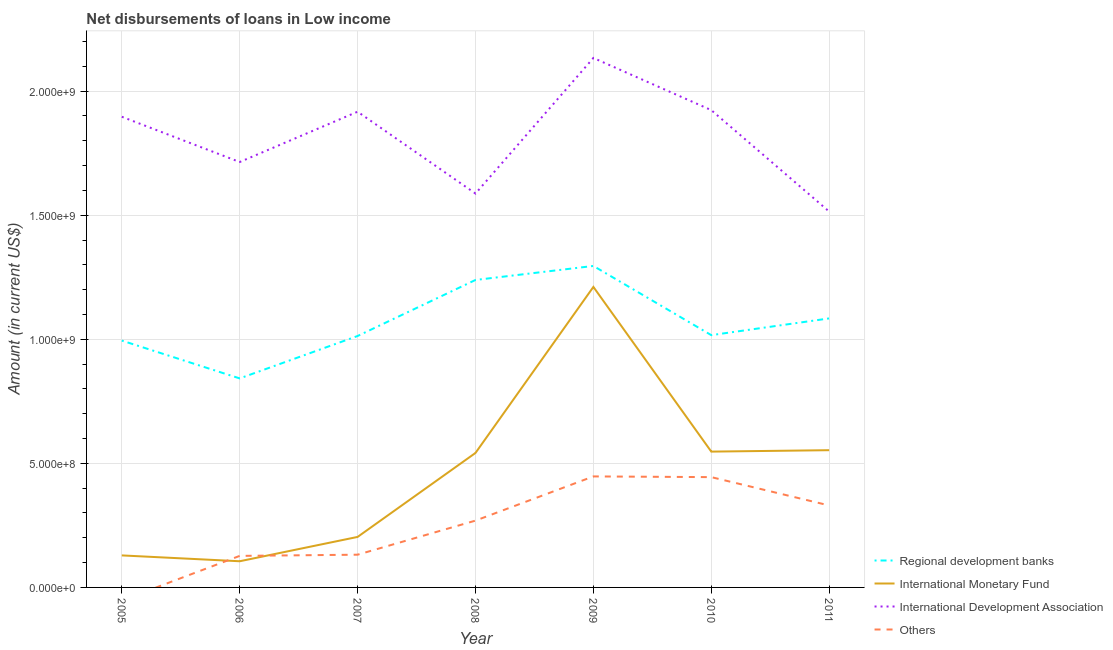How many different coloured lines are there?
Offer a terse response. 4. What is the amount of loan disimbursed by other organisations in 2011?
Offer a very short reply. 3.30e+08. Across all years, what is the maximum amount of loan disimbursed by international monetary fund?
Your answer should be compact. 1.21e+09. Across all years, what is the minimum amount of loan disimbursed by other organisations?
Provide a succinct answer. 0. In which year was the amount of loan disimbursed by regional development banks maximum?
Your answer should be compact. 2009. What is the total amount of loan disimbursed by regional development banks in the graph?
Provide a succinct answer. 7.49e+09. What is the difference between the amount of loan disimbursed by regional development banks in 2005 and that in 2006?
Your answer should be very brief. 1.52e+08. What is the difference between the amount of loan disimbursed by international monetary fund in 2009 and the amount of loan disimbursed by regional development banks in 2005?
Provide a succinct answer. 2.16e+08. What is the average amount of loan disimbursed by other organisations per year?
Offer a very short reply. 2.50e+08. In the year 2006, what is the difference between the amount of loan disimbursed by regional development banks and amount of loan disimbursed by international development association?
Ensure brevity in your answer.  -8.72e+08. What is the ratio of the amount of loan disimbursed by other organisations in 2007 to that in 2009?
Make the answer very short. 0.29. Is the amount of loan disimbursed by international development association in 2006 less than that in 2009?
Offer a very short reply. Yes. What is the difference between the highest and the second highest amount of loan disimbursed by international monetary fund?
Keep it short and to the point. 6.58e+08. What is the difference between the highest and the lowest amount of loan disimbursed by other organisations?
Keep it short and to the point. 4.47e+08. Is the sum of the amount of loan disimbursed by other organisations in 2008 and 2011 greater than the maximum amount of loan disimbursed by international development association across all years?
Give a very brief answer. No. Is it the case that in every year, the sum of the amount of loan disimbursed by international development association and amount of loan disimbursed by regional development banks is greater than the sum of amount of loan disimbursed by other organisations and amount of loan disimbursed by international monetary fund?
Offer a terse response. No. Is it the case that in every year, the sum of the amount of loan disimbursed by regional development banks and amount of loan disimbursed by international monetary fund is greater than the amount of loan disimbursed by international development association?
Offer a very short reply. No. Does the amount of loan disimbursed by international monetary fund monotonically increase over the years?
Your answer should be compact. No. Is the amount of loan disimbursed by international development association strictly greater than the amount of loan disimbursed by other organisations over the years?
Your response must be concise. Yes. Is the amount of loan disimbursed by international monetary fund strictly less than the amount of loan disimbursed by regional development banks over the years?
Provide a short and direct response. Yes. What is the difference between two consecutive major ticks on the Y-axis?
Give a very brief answer. 5.00e+08. Does the graph contain any zero values?
Make the answer very short. Yes. Does the graph contain grids?
Offer a terse response. Yes. What is the title of the graph?
Your answer should be compact. Net disbursements of loans in Low income. What is the label or title of the X-axis?
Your answer should be very brief. Year. What is the Amount (in current US$) of Regional development banks in 2005?
Your answer should be compact. 9.95e+08. What is the Amount (in current US$) of International Monetary Fund in 2005?
Provide a succinct answer. 1.29e+08. What is the Amount (in current US$) in International Development Association in 2005?
Keep it short and to the point. 1.90e+09. What is the Amount (in current US$) in Regional development banks in 2006?
Provide a succinct answer. 8.42e+08. What is the Amount (in current US$) in International Monetary Fund in 2006?
Provide a succinct answer. 1.05e+08. What is the Amount (in current US$) of International Development Association in 2006?
Offer a very short reply. 1.71e+09. What is the Amount (in current US$) in Others in 2006?
Your response must be concise. 1.27e+08. What is the Amount (in current US$) of Regional development banks in 2007?
Your answer should be compact. 1.01e+09. What is the Amount (in current US$) of International Monetary Fund in 2007?
Keep it short and to the point. 2.04e+08. What is the Amount (in current US$) of International Development Association in 2007?
Give a very brief answer. 1.92e+09. What is the Amount (in current US$) in Others in 2007?
Provide a short and direct response. 1.32e+08. What is the Amount (in current US$) in Regional development banks in 2008?
Offer a terse response. 1.24e+09. What is the Amount (in current US$) in International Monetary Fund in 2008?
Your answer should be compact. 5.42e+08. What is the Amount (in current US$) in International Development Association in 2008?
Your answer should be very brief. 1.59e+09. What is the Amount (in current US$) of Others in 2008?
Make the answer very short. 2.69e+08. What is the Amount (in current US$) in Regional development banks in 2009?
Offer a terse response. 1.30e+09. What is the Amount (in current US$) in International Monetary Fund in 2009?
Provide a short and direct response. 1.21e+09. What is the Amount (in current US$) in International Development Association in 2009?
Keep it short and to the point. 2.13e+09. What is the Amount (in current US$) in Others in 2009?
Ensure brevity in your answer.  4.47e+08. What is the Amount (in current US$) in Regional development banks in 2010?
Provide a succinct answer. 1.02e+09. What is the Amount (in current US$) in International Monetary Fund in 2010?
Offer a very short reply. 5.47e+08. What is the Amount (in current US$) in International Development Association in 2010?
Offer a very short reply. 1.92e+09. What is the Amount (in current US$) in Others in 2010?
Make the answer very short. 4.45e+08. What is the Amount (in current US$) in Regional development banks in 2011?
Your answer should be very brief. 1.08e+09. What is the Amount (in current US$) in International Monetary Fund in 2011?
Give a very brief answer. 5.53e+08. What is the Amount (in current US$) of International Development Association in 2011?
Your response must be concise. 1.51e+09. What is the Amount (in current US$) in Others in 2011?
Provide a short and direct response. 3.30e+08. Across all years, what is the maximum Amount (in current US$) in Regional development banks?
Provide a short and direct response. 1.30e+09. Across all years, what is the maximum Amount (in current US$) of International Monetary Fund?
Provide a succinct answer. 1.21e+09. Across all years, what is the maximum Amount (in current US$) of International Development Association?
Keep it short and to the point. 2.13e+09. Across all years, what is the maximum Amount (in current US$) in Others?
Offer a terse response. 4.47e+08. Across all years, what is the minimum Amount (in current US$) of Regional development banks?
Provide a succinct answer. 8.42e+08. Across all years, what is the minimum Amount (in current US$) of International Monetary Fund?
Keep it short and to the point. 1.05e+08. Across all years, what is the minimum Amount (in current US$) of International Development Association?
Your answer should be compact. 1.51e+09. What is the total Amount (in current US$) in Regional development banks in the graph?
Make the answer very short. 7.49e+09. What is the total Amount (in current US$) of International Monetary Fund in the graph?
Offer a terse response. 3.29e+09. What is the total Amount (in current US$) of International Development Association in the graph?
Your answer should be very brief. 1.27e+1. What is the total Amount (in current US$) in Others in the graph?
Offer a very short reply. 1.75e+09. What is the difference between the Amount (in current US$) in Regional development banks in 2005 and that in 2006?
Offer a terse response. 1.52e+08. What is the difference between the Amount (in current US$) of International Monetary Fund in 2005 and that in 2006?
Provide a short and direct response. 2.36e+07. What is the difference between the Amount (in current US$) in International Development Association in 2005 and that in 2006?
Offer a terse response. 1.82e+08. What is the difference between the Amount (in current US$) of Regional development banks in 2005 and that in 2007?
Provide a succinct answer. -1.85e+07. What is the difference between the Amount (in current US$) of International Monetary Fund in 2005 and that in 2007?
Keep it short and to the point. -7.45e+07. What is the difference between the Amount (in current US$) in International Development Association in 2005 and that in 2007?
Keep it short and to the point. -2.03e+07. What is the difference between the Amount (in current US$) in Regional development banks in 2005 and that in 2008?
Ensure brevity in your answer.  -2.44e+08. What is the difference between the Amount (in current US$) in International Monetary Fund in 2005 and that in 2008?
Offer a terse response. -4.13e+08. What is the difference between the Amount (in current US$) in International Development Association in 2005 and that in 2008?
Keep it short and to the point. 3.09e+08. What is the difference between the Amount (in current US$) of Regional development banks in 2005 and that in 2009?
Provide a short and direct response. -3.01e+08. What is the difference between the Amount (in current US$) in International Monetary Fund in 2005 and that in 2009?
Keep it short and to the point. -1.08e+09. What is the difference between the Amount (in current US$) of International Development Association in 2005 and that in 2009?
Provide a succinct answer. -2.37e+08. What is the difference between the Amount (in current US$) in Regional development banks in 2005 and that in 2010?
Give a very brief answer. -2.20e+07. What is the difference between the Amount (in current US$) in International Monetary Fund in 2005 and that in 2010?
Make the answer very short. -4.18e+08. What is the difference between the Amount (in current US$) in International Development Association in 2005 and that in 2010?
Provide a short and direct response. -2.67e+07. What is the difference between the Amount (in current US$) of Regional development banks in 2005 and that in 2011?
Provide a short and direct response. -8.94e+07. What is the difference between the Amount (in current US$) in International Monetary Fund in 2005 and that in 2011?
Your response must be concise. -4.24e+08. What is the difference between the Amount (in current US$) in International Development Association in 2005 and that in 2011?
Your answer should be very brief. 3.82e+08. What is the difference between the Amount (in current US$) of Regional development banks in 2006 and that in 2007?
Your response must be concise. -1.71e+08. What is the difference between the Amount (in current US$) of International Monetary Fund in 2006 and that in 2007?
Your response must be concise. -9.81e+07. What is the difference between the Amount (in current US$) in International Development Association in 2006 and that in 2007?
Your answer should be compact. -2.03e+08. What is the difference between the Amount (in current US$) in Others in 2006 and that in 2007?
Your answer should be very brief. -4.82e+06. What is the difference between the Amount (in current US$) of Regional development banks in 2006 and that in 2008?
Provide a succinct answer. -3.97e+08. What is the difference between the Amount (in current US$) of International Monetary Fund in 2006 and that in 2008?
Ensure brevity in your answer.  -4.37e+08. What is the difference between the Amount (in current US$) in International Development Association in 2006 and that in 2008?
Provide a short and direct response. 1.27e+08. What is the difference between the Amount (in current US$) of Others in 2006 and that in 2008?
Your answer should be compact. -1.42e+08. What is the difference between the Amount (in current US$) of Regional development banks in 2006 and that in 2009?
Keep it short and to the point. -4.53e+08. What is the difference between the Amount (in current US$) in International Monetary Fund in 2006 and that in 2009?
Provide a short and direct response. -1.11e+09. What is the difference between the Amount (in current US$) in International Development Association in 2006 and that in 2009?
Your answer should be compact. -4.19e+08. What is the difference between the Amount (in current US$) in Others in 2006 and that in 2009?
Your answer should be very brief. -3.20e+08. What is the difference between the Amount (in current US$) of Regional development banks in 2006 and that in 2010?
Provide a short and direct response. -1.74e+08. What is the difference between the Amount (in current US$) of International Monetary Fund in 2006 and that in 2010?
Keep it short and to the point. -4.42e+08. What is the difference between the Amount (in current US$) in International Development Association in 2006 and that in 2010?
Your response must be concise. -2.09e+08. What is the difference between the Amount (in current US$) in Others in 2006 and that in 2010?
Your response must be concise. -3.17e+08. What is the difference between the Amount (in current US$) of Regional development banks in 2006 and that in 2011?
Ensure brevity in your answer.  -2.42e+08. What is the difference between the Amount (in current US$) of International Monetary Fund in 2006 and that in 2011?
Offer a terse response. -4.48e+08. What is the difference between the Amount (in current US$) of International Development Association in 2006 and that in 2011?
Keep it short and to the point. 2.00e+08. What is the difference between the Amount (in current US$) in Others in 2006 and that in 2011?
Provide a succinct answer. -2.03e+08. What is the difference between the Amount (in current US$) in Regional development banks in 2007 and that in 2008?
Make the answer very short. -2.26e+08. What is the difference between the Amount (in current US$) of International Monetary Fund in 2007 and that in 2008?
Your answer should be very brief. -3.38e+08. What is the difference between the Amount (in current US$) of International Development Association in 2007 and that in 2008?
Your answer should be very brief. 3.30e+08. What is the difference between the Amount (in current US$) of Others in 2007 and that in 2008?
Offer a terse response. -1.37e+08. What is the difference between the Amount (in current US$) in Regional development banks in 2007 and that in 2009?
Provide a short and direct response. -2.82e+08. What is the difference between the Amount (in current US$) of International Monetary Fund in 2007 and that in 2009?
Ensure brevity in your answer.  -1.01e+09. What is the difference between the Amount (in current US$) of International Development Association in 2007 and that in 2009?
Your answer should be compact. -2.17e+08. What is the difference between the Amount (in current US$) in Others in 2007 and that in 2009?
Offer a very short reply. -3.15e+08. What is the difference between the Amount (in current US$) in Regional development banks in 2007 and that in 2010?
Offer a terse response. -3.46e+06. What is the difference between the Amount (in current US$) of International Monetary Fund in 2007 and that in 2010?
Provide a short and direct response. -3.44e+08. What is the difference between the Amount (in current US$) in International Development Association in 2007 and that in 2010?
Offer a very short reply. -6.39e+06. What is the difference between the Amount (in current US$) in Others in 2007 and that in 2010?
Ensure brevity in your answer.  -3.13e+08. What is the difference between the Amount (in current US$) of Regional development banks in 2007 and that in 2011?
Your response must be concise. -7.09e+07. What is the difference between the Amount (in current US$) of International Monetary Fund in 2007 and that in 2011?
Give a very brief answer. -3.50e+08. What is the difference between the Amount (in current US$) in International Development Association in 2007 and that in 2011?
Make the answer very short. 4.02e+08. What is the difference between the Amount (in current US$) of Others in 2007 and that in 2011?
Ensure brevity in your answer.  -1.98e+08. What is the difference between the Amount (in current US$) of Regional development banks in 2008 and that in 2009?
Make the answer very short. -5.64e+07. What is the difference between the Amount (in current US$) in International Monetary Fund in 2008 and that in 2009?
Provide a short and direct response. -6.69e+08. What is the difference between the Amount (in current US$) in International Development Association in 2008 and that in 2009?
Offer a terse response. -5.46e+08. What is the difference between the Amount (in current US$) in Others in 2008 and that in 2009?
Offer a terse response. -1.78e+08. What is the difference between the Amount (in current US$) of Regional development banks in 2008 and that in 2010?
Provide a succinct answer. 2.22e+08. What is the difference between the Amount (in current US$) of International Monetary Fund in 2008 and that in 2010?
Keep it short and to the point. -5.36e+06. What is the difference between the Amount (in current US$) of International Development Association in 2008 and that in 2010?
Give a very brief answer. -3.36e+08. What is the difference between the Amount (in current US$) of Others in 2008 and that in 2010?
Your response must be concise. -1.75e+08. What is the difference between the Amount (in current US$) of Regional development banks in 2008 and that in 2011?
Make the answer very short. 1.55e+08. What is the difference between the Amount (in current US$) in International Monetary Fund in 2008 and that in 2011?
Offer a very short reply. -1.11e+07. What is the difference between the Amount (in current US$) of International Development Association in 2008 and that in 2011?
Make the answer very short. 7.26e+07. What is the difference between the Amount (in current US$) in Others in 2008 and that in 2011?
Your answer should be compact. -6.11e+07. What is the difference between the Amount (in current US$) of Regional development banks in 2009 and that in 2010?
Ensure brevity in your answer.  2.79e+08. What is the difference between the Amount (in current US$) of International Monetary Fund in 2009 and that in 2010?
Provide a succinct answer. 6.64e+08. What is the difference between the Amount (in current US$) in International Development Association in 2009 and that in 2010?
Your answer should be compact. 2.10e+08. What is the difference between the Amount (in current US$) in Others in 2009 and that in 2010?
Your answer should be very brief. 2.87e+06. What is the difference between the Amount (in current US$) of Regional development banks in 2009 and that in 2011?
Ensure brevity in your answer.  2.11e+08. What is the difference between the Amount (in current US$) in International Monetary Fund in 2009 and that in 2011?
Your answer should be very brief. 6.58e+08. What is the difference between the Amount (in current US$) of International Development Association in 2009 and that in 2011?
Your response must be concise. 6.19e+08. What is the difference between the Amount (in current US$) in Others in 2009 and that in 2011?
Your response must be concise. 1.17e+08. What is the difference between the Amount (in current US$) in Regional development banks in 2010 and that in 2011?
Make the answer very short. -6.74e+07. What is the difference between the Amount (in current US$) of International Monetary Fund in 2010 and that in 2011?
Make the answer very short. -5.76e+06. What is the difference between the Amount (in current US$) in International Development Association in 2010 and that in 2011?
Your response must be concise. 4.09e+08. What is the difference between the Amount (in current US$) in Others in 2010 and that in 2011?
Make the answer very short. 1.14e+08. What is the difference between the Amount (in current US$) in Regional development banks in 2005 and the Amount (in current US$) in International Monetary Fund in 2006?
Your answer should be very brief. 8.89e+08. What is the difference between the Amount (in current US$) in Regional development banks in 2005 and the Amount (in current US$) in International Development Association in 2006?
Give a very brief answer. -7.20e+08. What is the difference between the Amount (in current US$) of Regional development banks in 2005 and the Amount (in current US$) of Others in 2006?
Offer a very short reply. 8.68e+08. What is the difference between the Amount (in current US$) in International Monetary Fund in 2005 and the Amount (in current US$) in International Development Association in 2006?
Your answer should be very brief. -1.59e+09. What is the difference between the Amount (in current US$) of International Monetary Fund in 2005 and the Amount (in current US$) of Others in 2006?
Your answer should be compact. 1.95e+06. What is the difference between the Amount (in current US$) in International Development Association in 2005 and the Amount (in current US$) in Others in 2006?
Your answer should be very brief. 1.77e+09. What is the difference between the Amount (in current US$) of Regional development banks in 2005 and the Amount (in current US$) of International Monetary Fund in 2007?
Your answer should be compact. 7.91e+08. What is the difference between the Amount (in current US$) of Regional development banks in 2005 and the Amount (in current US$) of International Development Association in 2007?
Keep it short and to the point. -9.22e+08. What is the difference between the Amount (in current US$) of Regional development banks in 2005 and the Amount (in current US$) of Others in 2007?
Your answer should be compact. 8.63e+08. What is the difference between the Amount (in current US$) in International Monetary Fund in 2005 and the Amount (in current US$) in International Development Association in 2007?
Offer a terse response. -1.79e+09. What is the difference between the Amount (in current US$) in International Monetary Fund in 2005 and the Amount (in current US$) in Others in 2007?
Your response must be concise. -2.87e+06. What is the difference between the Amount (in current US$) of International Development Association in 2005 and the Amount (in current US$) of Others in 2007?
Your answer should be very brief. 1.76e+09. What is the difference between the Amount (in current US$) in Regional development banks in 2005 and the Amount (in current US$) in International Monetary Fund in 2008?
Ensure brevity in your answer.  4.53e+08. What is the difference between the Amount (in current US$) in Regional development banks in 2005 and the Amount (in current US$) in International Development Association in 2008?
Ensure brevity in your answer.  -5.93e+08. What is the difference between the Amount (in current US$) of Regional development banks in 2005 and the Amount (in current US$) of Others in 2008?
Give a very brief answer. 7.26e+08. What is the difference between the Amount (in current US$) in International Monetary Fund in 2005 and the Amount (in current US$) in International Development Association in 2008?
Make the answer very short. -1.46e+09. What is the difference between the Amount (in current US$) of International Monetary Fund in 2005 and the Amount (in current US$) of Others in 2008?
Your response must be concise. -1.40e+08. What is the difference between the Amount (in current US$) of International Development Association in 2005 and the Amount (in current US$) of Others in 2008?
Provide a short and direct response. 1.63e+09. What is the difference between the Amount (in current US$) of Regional development banks in 2005 and the Amount (in current US$) of International Monetary Fund in 2009?
Your answer should be compact. -2.16e+08. What is the difference between the Amount (in current US$) in Regional development banks in 2005 and the Amount (in current US$) in International Development Association in 2009?
Your answer should be very brief. -1.14e+09. What is the difference between the Amount (in current US$) in Regional development banks in 2005 and the Amount (in current US$) in Others in 2009?
Keep it short and to the point. 5.47e+08. What is the difference between the Amount (in current US$) of International Monetary Fund in 2005 and the Amount (in current US$) of International Development Association in 2009?
Ensure brevity in your answer.  -2.00e+09. What is the difference between the Amount (in current US$) of International Monetary Fund in 2005 and the Amount (in current US$) of Others in 2009?
Keep it short and to the point. -3.18e+08. What is the difference between the Amount (in current US$) of International Development Association in 2005 and the Amount (in current US$) of Others in 2009?
Your answer should be compact. 1.45e+09. What is the difference between the Amount (in current US$) in Regional development banks in 2005 and the Amount (in current US$) in International Monetary Fund in 2010?
Your response must be concise. 4.47e+08. What is the difference between the Amount (in current US$) of Regional development banks in 2005 and the Amount (in current US$) of International Development Association in 2010?
Your answer should be compact. -9.29e+08. What is the difference between the Amount (in current US$) in Regional development banks in 2005 and the Amount (in current US$) in Others in 2010?
Keep it short and to the point. 5.50e+08. What is the difference between the Amount (in current US$) of International Monetary Fund in 2005 and the Amount (in current US$) of International Development Association in 2010?
Keep it short and to the point. -1.79e+09. What is the difference between the Amount (in current US$) in International Monetary Fund in 2005 and the Amount (in current US$) in Others in 2010?
Ensure brevity in your answer.  -3.15e+08. What is the difference between the Amount (in current US$) in International Development Association in 2005 and the Amount (in current US$) in Others in 2010?
Your answer should be very brief. 1.45e+09. What is the difference between the Amount (in current US$) in Regional development banks in 2005 and the Amount (in current US$) in International Monetary Fund in 2011?
Your answer should be compact. 4.42e+08. What is the difference between the Amount (in current US$) in Regional development banks in 2005 and the Amount (in current US$) in International Development Association in 2011?
Your answer should be compact. -5.20e+08. What is the difference between the Amount (in current US$) of Regional development banks in 2005 and the Amount (in current US$) of Others in 2011?
Offer a terse response. 6.64e+08. What is the difference between the Amount (in current US$) of International Monetary Fund in 2005 and the Amount (in current US$) of International Development Association in 2011?
Offer a very short reply. -1.39e+09. What is the difference between the Amount (in current US$) in International Monetary Fund in 2005 and the Amount (in current US$) in Others in 2011?
Offer a very short reply. -2.01e+08. What is the difference between the Amount (in current US$) in International Development Association in 2005 and the Amount (in current US$) in Others in 2011?
Give a very brief answer. 1.57e+09. What is the difference between the Amount (in current US$) in Regional development banks in 2006 and the Amount (in current US$) in International Monetary Fund in 2007?
Your answer should be very brief. 6.39e+08. What is the difference between the Amount (in current US$) in Regional development banks in 2006 and the Amount (in current US$) in International Development Association in 2007?
Provide a succinct answer. -1.07e+09. What is the difference between the Amount (in current US$) in Regional development banks in 2006 and the Amount (in current US$) in Others in 2007?
Your answer should be compact. 7.10e+08. What is the difference between the Amount (in current US$) of International Monetary Fund in 2006 and the Amount (in current US$) of International Development Association in 2007?
Offer a terse response. -1.81e+09. What is the difference between the Amount (in current US$) in International Monetary Fund in 2006 and the Amount (in current US$) in Others in 2007?
Make the answer very short. -2.64e+07. What is the difference between the Amount (in current US$) of International Development Association in 2006 and the Amount (in current US$) of Others in 2007?
Offer a terse response. 1.58e+09. What is the difference between the Amount (in current US$) in Regional development banks in 2006 and the Amount (in current US$) in International Monetary Fund in 2008?
Your answer should be compact. 3.00e+08. What is the difference between the Amount (in current US$) of Regional development banks in 2006 and the Amount (in current US$) of International Development Association in 2008?
Your answer should be compact. -7.45e+08. What is the difference between the Amount (in current US$) of Regional development banks in 2006 and the Amount (in current US$) of Others in 2008?
Your answer should be compact. 5.73e+08. What is the difference between the Amount (in current US$) in International Monetary Fund in 2006 and the Amount (in current US$) in International Development Association in 2008?
Keep it short and to the point. -1.48e+09. What is the difference between the Amount (in current US$) of International Monetary Fund in 2006 and the Amount (in current US$) of Others in 2008?
Offer a terse response. -1.64e+08. What is the difference between the Amount (in current US$) in International Development Association in 2006 and the Amount (in current US$) in Others in 2008?
Offer a very short reply. 1.45e+09. What is the difference between the Amount (in current US$) of Regional development banks in 2006 and the Amount (in current US$) of International Monetary Fund in 2009?
Provide a succinct answer. -3.69e+08. What is the difference between the Amount (in current US$) of Regional development banks in 2006 and the Amount (in current US$) of International Development Association in 2009?
Your answer should be compact. -1.29e+09. What is the difference between the Amount (in current US$) of Regional development banks in 2006 and the Amount (in current US$) of Others in 2009?
Your answer should be very brief. 3.95e+08. What is the difference between the Amount (in current US$) in International Monetary Fund in 2006 and the Amount (in current US$) in International Development Association in 2009?
Your answer should be compact. -2.03e+09. What is the difference between the Amount (in current US$) in International Monetary Fund in 2006 and the Amount (in current US$) in Others in 2009?
Your answer should be very brief. -3.42e+08. What is the difference between the Amount (in current US$) of International Development Association in 2006 and the Amount (in current US$) of Others in 2009?
Offer a terse response. 1.27e+09. What is the difference between the Amount (in current US$) in Regional development banks in 2006 and the Amount (in current US$) in International Monetary Fund in 2010?
Make the answer very short. 2.95e+08. What is the difference between the Amount (in current US$) in Regional development banks in 2006 and the Amount (in current US$) in International Development Association in 2010?
Your response must be concise. -1.08e+09. What is the difference between the Amount (in current US$) of Regional development banks in 2006 and the Amount (in current US$) of Others in 2010?
Your answer should be compact. 3.98e+08. What is the difference between the Amount (in current US$) of International Monetary Fund in 2006 and the Amount (in current US$) of International Development Association in 2010?
Give a very brief answer. -1.82e+09. What is the difference between the Amount (in current US$) in International Monetary Fund in 2006 and the Amount (in current US$) in Others in 2010?
Provide a succinct answer. -3.39e+08. What is the difference between the Amount (in current US$) of International Development Association in 2006 and the Amount (in current US$) of Others in 2010?
Your answer should be compact. 1.27e+09. What is the difference between the Amount (in current US$) of Regional development banks in 2006 and the Amount (in current US$) of International Monetary Fund in 2011?
Your answer should be compact. 2.89e+08. What is the difference between the Amount (in current US$) in Regional development banks in 2006 and the Amount (in current US$) in International Development Association in 2011?
Your answer should be very brief. -6.72e+08. What is the difference between the Amount (in current US$) of Regional development banks in 2006 and the Amount (in current US$) of Others in 2011?
Your answer should be very brief. 5.12e+08. What is the difference between the Amount (in current US$) in International Monetary Fund in 2006 and the Amount (in current US$) in International Development Association in 2011?
Your response must be concise. -1.41e+09. What is the difference between the Amount (in current US$) of International Monetary Fund in 2006 and the Amount (in current US$) of Others in 2011?
Make the answer very short. -2.25e+08. What is the difference between the Amount (in current US$) of International Development Association in 2006 and the Amount (in current US$) of Others in 2011?
Your answer should be very brief. 1.38e+09. What is the difference between the Amount (in current US$) of Regional development banks in 2007 and the Amount (in current US$) of International Monetary Fund in 2008?
Give a very brief answer. 4.71e+08. What is the difference between the Amount (in current US$) in Regional development banks in 2007 and the Amount (in current US$) in International Development Association in 2008?
Your answer should be very brief. -5.74e+08. What is the difference between the Amount (in current US$) of Regional development banks in 2007 and the Amount (in current US$) of Others in 2008?
Provide a succinct answer. 7.44e+08. What is the difference between the Amount (in current US$) in International Monetary Fund in 2007 and the Amount (in current US$) in International Development Association in 2008?
Keep it short and to the point. -1.38e+09. What is the difference between the Amount (in current US$) of International Monetary Fund in 2007 and the Amount (in current US$) of Others in 2008?
Ensure brevity in your answer.  -6.57e+07. What is the difference between the Amount (in current US$) of International Development Association in 2007 and the Amount (in current US$) of Others in 2008?
Offer a very short reply. 1.65e+09. What is the difference between the Amount (in current US$) of Regional development banks in 2007 and the Amount (in current US$) of International Monetary Fund in 2009?
Keep it short and to the point. -1.98e+08. What is the difference between the Amount (in current US$) in Regional development banks in 2007 and the Amount (in current US$) in International Development Association in 2009?
Provide a succinct answer. -1.12e+09. What is the difference between the Amount (in current US$) in Regional development banks in 2007 and the Amount (in current US$) in Others in 2009?
Offer a very short reply. 5.66e+08. What is the difference between the Amount (in current US$) in International Monetary Fund in 2007 and the Amount (in current US$) in International Development Association in 2009?
Your answer should be compact. -1.93e+09. What is the difference between the Amount (in current US$) of International Monetary Fund in 2007 and the Amount (in current US$) of Others in 2009?
Give a very brief answer. -2.44e+08. What is the difference between the Amount (in current US$) of International Development Association in 2007 and the Amount (in current US$) of Others in 2009?
Offer a very short reply. 1.47e+09. What is the difference between the Amount (in current US$) of Regional development banks in 2007 and the Amount (in current US$) of International Monetary Fund in 2010?
Provide a succinct answer. 4.66e+08. What is the difference between the Amount (in current US$) of Regional development banks in 2007 and the Amount (in current US$) of International Development Association in 2010?
Offer a very short reply. -9.10e+08. What is the difference between the Amount (in current US$) of Regional development banks in 2007 and the Amount (in current US$) of Others in 2010?
Your answer should be compact. 5.69e+08. What is the difference between the Amount (in current US$) in International Monetary Fund in 2007 and the Amount (in current US$) in International Development Association in 2010?
Your response must be concise. -1.72e+09. What is the difference between the Amount (in current US$) of International Monetary Fund in 2007 and the Amount (in current US$) of Others in 2010?
Make the answer very short. -2.41e+08. What is the difference between the Amount (in current US$) of International Development Association in 2007 and the Amount (in current US$) of Others in 2010?
Your response must be concise. 1.47e+09. What is the difference between the Amount (in current US$) in Regional development banks in 2007 and the Amount (in current US$) in International Monetary Fund in 2011?
Your answer should be very brief. 4.60e+08. What is the difference between the Amount (in current US$) in Regional development banks in 2007 and the Amount (in current US$) in International Development Association in 2011?
Make the answer very short. -5.02e+08. What is the difference between the Amount (in current US$) of Regional development banks in 2007 and the Amount (in current US$) of Others in 2011?
Make the answer very short. 6.83e+08. What is the difference between the Amount (in current US$) of International Monetary Fund in 2007 and the Amount (in current US$) of International Development Association in 2011?
Give a very brief answer. -1.31e+09. What is the difference between the Amount (in current US$) in International Monetary Fund in 2007 and the Amount (in current US$) in Others in 2011?
Your answer should be very brief. -1.27e+08. What is the difference between the Amount (in current US$) of International Development Association in 2007 and the Amount (in current US$) of Others in 2011?
Ensure brevity in your answer.  1.59e+09. What is the difference between the Amount (in current US$) of Regional development banks in 2008 and the Amount (in current US$) of International Monetary Fund in 2009?
Ensure brevity in your answer.  2.81e+07. What is the difference between the Amount (in current US$) in Regional development banks in 2008 and the Amount (in current US$) in International Development Association in 2009?
Keep it short and to the point. -8.95e+08. What is the difference between the Amount (in current US$) in Regional development banks in 2008 and the Amount (in current US$) in Others in 2009?
Keep it short and to the point. 7.92e+08. What is the difference between the Amount (in current US$) in International Monetary Fund in 2008 and the Amount (in current US$) in International Development Association in 2009?
Your answer should be very brief. -1.59e+09. What is the difference between the Amount (in current US$) in International Monetary Fund in 2008 and the Amount (in current US$) in Others in 2009?
Offer a very short reply. 9.46e+07. What is the difference between the Amount (in current US$) in International Development Association in 2008 and the Amount (in current US$) in Others in 2009?
Your answer should be compact. 1.14e+09. What is the difference between the Amount (in current US$) of Regional development banks in 2008 and the Amount (in current US$) of International Monetary Fund in 2010?
Make the answer very short. 6.92e+08. What is the difference between the Amount (in current US$) of Regional development banks in 2008 and the Amount (in current US$) of International Development Association in 2010?
Offer a terse response. -6.84e+08. What is the difference between the Amount (in current US$) in Regional development banks in 2008 and the Amount (in current US$) in Others in 2010?
Provide a succinct answer. 7.95e+08. What is the difference between the Amount (in current US$) of International Monetary Fund in 2008 and the Amount (in current US$) of International Development Association in 2010?
Your answer should be very brief. -1.38e+09. What is the difference between the Amount (in current US$) in International Monetary Fund in 2008 and the Amount (in current US$) in Others in 2010?
Your answer should be compact. 9.75e+07. What is the difference between the Amount (in current US$) of International Development Association in 2008 and the Amount (in current US$) of Others in 2010?
Keep it short and to the point. 1.14e+09. What is the difference between the Amount (in current US$) of Regional development banks in 2008 and the Amount (in current US$) of International Monetary Fund in 2011?
Offer a very short reply. 6.86e+08. What is the difference between the Amount (in current US$) of Regional development banks in 2008 and the Amount (in current US$) of International Development Association in 2011?
Your response must be concise. -2.76e+08. What is the difference between the Amount (in current US$) of Regional development banks in 2008 and the Amount (in current US$) of Others in 2011?
Ensure brevity in your answer.  9.09e+08. What is the difference between the Amount (in current US$) of International Monetary Fund in 2008 and the Amount (in current US$) of International Development Association in 2011?
Provide a succinct answer. -9.73e+08. What is the difference between the Amount (in current US$) of International Monetary Fund in 2008 and the Amount (in current US$) of Others in 2011?
Your answer should be compact. 2.12e+08. What is the difference between the Amount (in current US$) of International Development Association in 2008 and the Amount (in current US$) of Others in 2011?
Provide a succinct answer. 1.26e+09. What is the difference between the Amount (in current US$) in Regional development banks in 2009 and the Amount (in current US$) in International Monetary Fund in 2010?
Ensure brevity in your answer.  7.48e+08. What is the difference between the Amount (in current US$) in Regional development banks in 2009 and the Amount (in current US$) in International Development Association in 2010?
Make the answer very short. -6.28e+08. What is the difference between the Amount (in current US$) in Regional development banks in 2009 and the Amount (in current US$) in Others in 2010?
Your answer should be very brief. 8.51e+08. What is the difference between the Amount (in current US$) in International Monetary Fund in 2009 and the Amount (in current US$) in International Development Association in 2010?
Keep it short and to the point. -7.12e+08. What is the difference between the Amount (in current US$) of International Monetary Fund in 2009 and the Amount (in current US$) of Others in 2010?
Your response must be concise. 7.67e+08. What is the difference between the Amount (in current US$) in International Development Association in 2009 and the Amount (in current US$) in Others in 2010?
Offer a terse response. 1.69e+09. What is the difference between the Amount (in current US$) in Regional development banks in 2009 and the Amount (in current US$) in International Monetary Fund in 2011?
Make the answer very short. 7.42e+08. What is the difference between the Amount (in current US$) of Regional development banks in 2009 and the Amount (in current US$) of International Development Association in 2011?
Offer a terse response. -2.19e+08. What is the difference between the Amount (in current US$) in Regional development banks in 2009 and the Amount (in current US$) in Others in 2011?
Ensure brevity in your answer.  9.65e+08. What is the difference between the Amount (in current US$) in International Monetary Fund in 2009 and the Amount (in current US$) in International Development Association in 2011?
Keep it short and to the point. -3.04e+08. What is the difference between the Amount (in current US$) of International Monetary Fund in 2009 and the Amount (in current US$) of Others in 2011?
Keep it short and to the point. 8.81e+08. What is the difference between the Amount (in current US$) in International Development Association in 2009 and the Amount (in current US$) in Others in 2011?
Give a very brief answer. 1.80e+09. What is the difference between the Amount (in current US$) in Regional development banks in 2010 and the Amount (in current US$) in International Monetary Fund in 2011?
Your answer should be very brief. 4.64e+08. What is the difference between the Amount (in current US$) in Regional development banks in 2010 and the Amount (in current US$) in International Development Association in 2011?
Keep it short and to the point. -4.98e+08. What is the difference between the Amount (in current US$) of Regional development banks in 2010 and the Amount (in current US$) of Others in 2011?
Ensure brevity in your answer.  6.86e+08. What is the difference between the Amount (in current US$) in International Monetary Fund in 2010 and the Amount (in current US$) in International Development Association in 2011?
Provide a short and direct response. -9.68e+08. What is the difference between the Amount (in current US$) of International Monetary Fund in 2010 and the Amount (in current US$) of Others in 2011?
Make the answer very short. 2.17e+08. What is the difference between the Amount (in current US$) of International Development Association in 2010 and the Amount (in current US$) of Others in 2011?
Your answer should be compact. 1.59e+09. What is the average Amount (in current US$) of Regional development banks per year?
Your answer should be very brief. 1.07e+09. What is the average Amount (in current US$) in International Monetary Fund per year?
Provide a succinct answer. 4.70e+08. What is the average Amount (in current US$) in International Development Association per year?
Your answer should be compact. 1.81e+09. What is the average Amount (in current US$) of Others per year?
Keep it short and to the point. 2.50e+08. In the year 2005, what is the difference between the Amount (in current US$) of Regional development banks and Amount (in current US$) of International Monetary Fund?
Provide a succinct answer. 8.66e+08. In the year 2005, what is the difference between the Amount (in current US$) of Regional development banks and Amount (in current US$) of International Development Association?
Provide a short and direct response. -9.02e+08. In the year 2005, what is the difference between the Amount (in current US$) in International Monetary Fund and Amount (in current US$) in International Development Association?
Make the answer very short. -1.77e+09. In the year 2006, what is the difference between the Amount (in current US$) in Regional development banks and Amount (in current US$) in International Monetary Fund?
Offer a very short reply. 7.37e+08. In the year 2006, what is the difference between the Amount (in current US$) of Regional development banks and Amount (in current US$) of International Development Association?
Provide a short and direct response. -8.72e+08. In the year 2006, what is the difference between the Amount (in current US$) in Regional development banks and Amount (in current US$) in Others?
Provide a short and direct response. 7.15e+08. In the year 2006, what is the difference between the Amount (in current US$) in International Monetary Fund and Amount (in current US$) in International Development Association?
Provide a succinct answer. -1.61e+09. In the year 2006, what is the difference between the Amount (in current US$) of International Monetary Fund and Amount (in current US$) of Others?
Ensure brevity in your answer.  -2.16e+07. In the year 2006, what is the difference between the Amount (in current US$) in International Development Association and Amount (in current US$) in Others?
Offer a very short reply. 1.59e+09. In the year 2007, what is the difference between the Amount (in current US$) in Regional development banks and Amount (in current US$) in International Monetary Fund?
Give a very brief answer. 8.10e+08. In the year 2007, what is the difference between the Amount (in current US$) in Regional development banks and Amount (in current US$) in International Development Association?
Make the answer very short. -9.04e+08. In the year 2007, what is the difference between the Amount (in current US$) of Regional development banks and Amount (in current US$) of Others?
Keep it short and to the point. 8.81e+08. In the year 2007, what is the difference between the Amount (in current US$) in International Monetary Fund and Amount (in current US$) in International Development Association?
Your answer should be compact. -1.71e+09. In the year 2007, what is the difference between the Amount (in current US$) in International Monetary Fund and Amount (in current US$) in Others?
Offer a terse response. 7.16e+07. In the year 2007, what is the difference between the Amount (in current US$) in International Development Association and Amount (in current US$) in Others?
Ensure brevity in your answer.  1.79e+09. In the year 2008, what is the difference between the Amount (in current US$) of Regional development banks and Amount (in current US$) of International Monetary Fund?
Give a very brief answer. 6.97e+08. In the year 2008, what is the difference between the Amount (in current US$) in Regional development banks and Amount (in current US$) in International Development Association?
Keep it short and to the point. -3.48e+08. In the year 2008, what is the difference between the Amount (in current US$) in Regional development banks and Amount (in current US$) in Others?
Keep it short and to the point. 9.70e+08. In the year 2008, what is the difference between the Amount (in current US$) of International Monetary Fund and Amount (in current US$) of International Development Association?
Your response must be concise. -1.05e+09. In the year 2008, what is the difference between the Amount (in current US$) in International Monetary Fund and Amount (in current US$) in Others?
Keep it short and to the point. 2.73e+08. In the year 2008, what is the difference between the Amount (in current US$) of International Development Association and Amount (in current US$) of Others?
Provide a succinct answer. 1.32e+09. In the year 2009, what is the difference between the Amount (in current US$) in Regional development banks and Amount (in current US$) in International Monetary Fund?
Make the answer very short. 8.45e+07. In the year 2009, what is the difference between the Amount (in current US$) of Regional development banks and Amount (in current US$) of International Development Association?
Give a very brief answer. -8.38e+08. In the year 2009, what is the difference between the Amount (in current US$) of Regional development banks and Amount (in current US$) of Others?
Offer a very short reply. 8.48e+08. In the year 2009, what is the difference between the Amount (in current US$) of International Monetary Fund and Amount (in current US$) of International Development Association?
Your response must be concise. -9.23e+08. In the year 2009, what is the difference between the Amount (in current US$) in International Monetary Fund and Amount (in current US$) in Others?
Your response must be concise. 7.64e+08. In the year 2009, what is the difference between the Amount (in current US$) of International Development Association and Amount (in current US$) of Others?
Ensure brevity in your answer.  1.69e+09. In the year 2010, what is the difference between the Amount (in current US$) in Regional development banks and Amount (in current US$) in International Monetary Fund?
Make the answer very short. 4.69e+08. In the year 2010, what is the difference between the Amount (in current US$) in Regional development banks and Amount (in current US$) in International Development Association?
Offer a terse response. -9.07e+08. In the year 2010, what is the difference between the Amount (in current US$) in Regional development banks and Amount (in current US$) in Others?
Offer a terse response. 5.72e+08. In the year 2010, what is the difference between the Amount (in current US$) of International Monetary Fund and Amount (in current US$) of International Development Association?
Provide a short and direct response. -1.38e+09. In the year 2010, what is the difference between the Amount (in current US$) of International Monetary Fund and Amount (in current US$) of Others?
Ensure brevity in your answer.  1.03e+08. In the year 2010, what is the difference between the Amount (in current US$) of International Development Association and Amount (in current US$) of Others?
Your response must be concise. 1.48e+09. In the year 2011, what is the difference between the Amount (in current US$) of Regional development banks and Amount (in current US$) of International Monetary Fund?
Provide a succinct answer. 5.31e+08. In the year 2011, what is the difference between the Amount (in current US$) in Regional development banks and Amount (in current US$) in International Development Association?
Provide a succinct answer. -4.31e+08. In the year 2011, what is the difference between the Amount (in current US$) in Regional development banks and Amount (in current US$) in Others?
Provide a succinct answer. 7.54e+08. In the year 2011, what is the difference between the Amount (in current US$) of International Monetary Fund and Amount (in current US$) of International Development Association?
Your response must be concise. -9.62e+08. In the year 2011, what is the difference between the Amount (in current US$) in International Monetary Fund and Amount (in current US$) in Others?
Offer a very short reply. 2.23e+08. In the year 2011, what is the difference between the Amount (in current US$) of International Development Association and Amount (in current US$) of Others?
Offer a terse response. 1.18e+09. What is the ratio of the Amount (in current US$) of Regional development banks in 2005 to that in 2006?
Your response must be concise. 1.18. What is the ratio of the Amount (in current US$) in International Monetary Fund in 2005 to that in 2006?
Your response must be concise. 1.22. What is the ratio of the Amount (in current US$) of International Development Association in 2005 to that in 2006?
Provide a short and direct response. 1.11. What is the ratio of the Amount (in current US$) of Regional development banks in 2005 to that in 2007?
Ensure brevity in your answer.  0.98. What is the ratio of the Amount (in current US$) in International Monetary Fund in 2005 to that in 2007?
Offer a very short reply. 0.63. What is the ratio of the Amount (in current US$) of Regional development banks in 2005 to that in 2008?
Offer a very short reply. 0.8. What is the ratio of the Amount (in current US$) of International Monetary Fund in 2005 to that in 2008?
Offer a terse response. 0.24. What is the ratio of the Amount (in current US$) in International Development Association in 2005 to that in 2008?
Provide a succinct answer. 1.19. What is the ratio of the Amount (in current US$) in Regional development banks in 2005 to that in 2009?
Offer a very short reply. 0.77. What is the ratio of the Amount (in current US$) in International Monetary Fund in 2005 to that in 2009?
Make the answer very short. 0.11. What is the ratio of the Amount (in current US$) of International Development Association in 2005 to that in 2009?
Offer a terse response. 0.89. What is the ratio of the Amount (in current US$) of Regional development banks in 2005 to that in 2010?
Offer a terse response. 0.98. What is the ratio of the Amount (in current US$) of International Monetary Fund in 2005 to that in 2010?
Your response must be concise. 0.24. What is the ratio of the Amount (in current US$) of International Development Association in 2005 to that in 2010?
Your answer should be very brief. 0.99. What is the ratio of the Amount (in current US$) of Regional development banks in 2005 to that in 2011?
Your answer should be compact. 0.92. What is the ratio of the Amount (in current US$) in International Monetary Fund in 2005 to that in 2011?
Offer a very short reply. 0.23. What is the ratio of the Amount (in current US$) of International Development Association in 2005 to that in 2011?
Keep it short and to the point. 1.25. What is the ratio of the Amount (in current US$) of Regional development banks in 2006 to that in 2007?
Make the answer very short. 0.83. What is the ratio of the Amount (in current US$) of International Monetary Fund in 2006 to that in 2007?
Provide a succinct answer. 0.52. What is the ratio of the Amount (in current US$) in International Development Association in 2006 to that in 2007?
Offer a terse response. 0.89. What is the ratio of the Amount (in current US$) of Others in 2006 to that in 2007?
Provide a succinct answer. 0.96. What is the ratio of the Amount (in current US$) in Regional development banks in 2006 to that in 2008?
Provide a short and direct response. 0.68. What is the ratio of the Amount (in current US$) in International Monetary Fund in 2006 to that in 2008?
Provide a short and direct response. 0.19. What is the ratio of the Amount (in current US$) in International Development Association in 2006 to that in 2008?
Your answer should be very brief. 1.08. What is the ratio of the Amount (in current US$) of Others in 2006 to that in 2008?
Offer a terse response. 0.47. What is the ratio of the Amount (in current US$) of Regional development banks in 2006 to that in 2009?
Your answer should be compact. 0.65. What is the ratio of the Amount (in current US$) of International Monetary Fund in 2006 to that in 2009?
Your answer should be compact. 0.09. What is the ratio of the Amount (in current US$) in International Development Association in 2006 to that in 2009?
Your answer should be compact. 0.8. What is the ratio of the Amount (in current US$) of Others in 2006 to that in 2009?
Your response must be concise. 0.28. What is the ratio of the Amount (in current US$) of Regional development banks in 2006 to that in 2010?
Provide a succinct answer. 0.83. What is the ratio of the Amount (in current US$) in International Monetary Fund in 2006 to that in 2010?
Your response must be concise. 0.19. What is the ratio of the Amount (in current US$) of International Development Association in 2006 to that in 2010?
Offer a very short reply. 0.89. What is the ratio of the Amount (in current US$) in Others in 2006 to that in 2010?
Your answer should be very brief. 0.29. What is the ratio of the Amount (in current US$) in Regional development banks in 2006 to that in 2011?
Offer a very short reply. 0.78. What is the ratio of the Amount (in current US$) of International Monetary Fund in 2006 to that in 2011?
Your answer should be very brief. 0.19. What is the ratio of the Amount (in current US$) in International Development Association in 2006 to that in 2011?
Your answer should be very brief. 1.13. What is the ratio of the Amount (in current US$) of Others in 2006 to that in 2011?
Provide a succinct answer. 0.38. What is the ratio of the Amount (in current US$) in Regional development banks in 2007 to that in 2008?
Provide a short and direct response. 0.82. What is the ratio of the Amount (in current US$) of International Monetary Fund in 2007 to that in 2008?
Offer a terse response. 0.38. What is the ratio of the Amount (in current US$) of International Development Association in 2007 to that in 2008?
Offer a terse response. 1.21. What is the ratio of the Amount (in current US$) in Others in 2007 to that in 2008?
Ensure brevity in your answer.  0.49. What is the ratio of the Amount (in current US$) of Regional development banks in 2007 to that in 2009?
Provide a succinct answer. 0.78. What is the ratio of the Amount (in current US$) in International Monetary Fund in 2007 to that in 2009?
Offer a terse response. 0.17. What is the ratio of the Amount (in current US$) in International Development Association in 2007 to that in 2009?
Ensure brevity in your answer.  0.9. What is the ratio of the Amount (in current US$) in Others in 2007 to that in 2009?
Your answer should be compact. 0.29. What is the ratio of the Amount (in current US$) in Regional development banks in 2007 to that in 2010?
Provide a succinct answer. 1. What is the ratio of the Amount (in current US$) of International Monetary Fund in 2007 to that in 2010?
Offer a very short reply. 0.37. What is the ratio of the Amount (in current US$) of International Development Association in 2007 to that in 2010?
Give a very brief answer. 1. What is the ratio of the Amount (in current US$) in Others in 2007 to that in 2010?
Give a very brief answer. 0.3. What is the ratio of the Amount (in current US$) in Regional development banks in 2007 to that in 2011?
Make the answer very short. 0.93. What is the ratio of the Amount (in current US$) of International Monetary Fund in 2007 to that in 2011?
Offer a terse response. 0.37. What is the ratio of the Amount (in current US$) of International Development Association in 2007 to that in 2011?
Your response must be concise. 1.27. What is the ratio of the Amount (in current US$) of Others in 2007 to that in 2011?
Give a very brief answer. 0.4. What is the ratio of the Amount (in current US$) in Regional development banks in 2008 to that in 2009?
Make the answer very short. 0.96. What is the ratio of the Amount (in current US$) of International Monetary Fund in 2008 to that in 2009?
Your answer should be compact. 0.45. What is the ratio of the Amount (in current US$) of International Development Association in 2008 to that in 2009?
Give a very brief answer. 0.74. What is the ratio of the Amount (in current US$) in Others in 2008 to that in 2009?
Give a very brief answer. 0.6. What is the ratio of the Amount (in current US$) in Regional development banks in 2008 to that in 2010?
Your answer should be very brief. 1.22. What is the ratio of the Amount (in current US$) of International Monetary Fund in 2008 to that in 2010?
Provide a succinct answer. 0.99. What is the ratio of the Amount (in current US$) of International Development Association in 2008 to that in 2010?
Give a very brief answer. 0.83. What is the ratio of the Amount (in current US$) of Others in 2008 to that in 2010?
Offer a very short reply. 0.61. What is the ratio of the Amount (in current US$) in International Monetary Fund in 2008 to that in 2011?
Give a very brief answer. 0.98. What is the ratio of the Amount (in current US$) in International Development Association in 2008 to that in 2011?
Your answer should be very brief. 1.05. What is the ratio of the Amount (in current US$) in Others in 2008 to that in 2011?
Provide a short and direct response. 0.82. What is the ratio of the Amount (in current US$) of Regional development banks in 2009 to that in 2010?
Your answer should be very brief. 1.27. What is the ratio of the Amount (in current US$) in International Monetary Fund in 2009 to that in 2010?
Offer a very short reply. 2.21. What is the ratio of the Amount (in current US$) of International Development Association in 2009 to that in 2010?
Offer a very short reply. 1.11. What is the ratio of the Amount (in current US$) in Regional development banks in 2009 to that in 2011?
Provide a short and direct response. 1.2. What is the ratio of the Amount (in current US$) in International Monetary Fund in 2009 to that in 2011?
Make the answer very short. 2.19. What is the ratio of the Amount (in current US$) of International Development Association in 2009 to that in 2011?
Provide a short and direct response. 1.41. What is the ratio of the Amount (in current US$) of Others in 2009 to that in 2011?
Make the answer very short. 1.35. What is the ratio of the Amount (in current US$) of Regional development banks in 2010 to that in 2011?
Provide a short and direct response. 0.94. What is the ratio of the Amount (in current US$) in International Development Association in 2010 to that in 2011?
Your answer should be compact. 1.27. What is the ratio of the Amount (in current US$) in Others in 2010 to that in 2011?
Offer a very short reply. 1.35. What is the difference between the highest and the second highest Amount (in current US$) of Regional development banks?
Offer a very short reply. 5.64e+07. What is the difference between the highest and the second highest Amount (in current US$) of International Monetary Fund?
Ensure brevity in your answer.  6.58e+08. What is the difference between the highest and the second highest Amount (in current US$) in International Development Association?
Offer a terse response. 2.10e+08. What is the difference between the highest and the second highest Amount (in current US$) of Others?
Give a very brief answer. 2.87e+06. What is the difference between the highest and the lowest Amount (in current US$) in Regional development banks?
Keep it short and to the point. 4.53e+08. What is the difference between the highest and the lowest Amount (in current US$) in International Monetary Fund?
Keep it short and to the point. 1.11e+09. What is the difference between the highest and the lowest Amount (in current US$) in International Development Association?
Your response must be concise. 6.19e+08. What is the difference between the highest and the lowest Amount (in current US$) of Others?
Make the answer very short. 4.47e+08. 